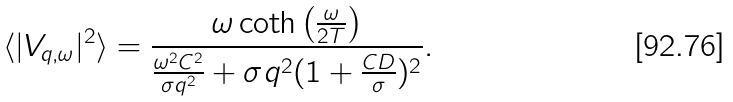Convert formula to latex. <formula><loc_0><loc_0><loc_500><loc_500>\langle | V _ { q , \omega } | ^ { 2 } \rangle = \frac { \omega \coth \left ( \frac { \omega } { 2 T } \right ) } { \frac { \omega ^ { 2 } C ^ { 2 } } { \sigma q ^ { 2 } } + \sigma q ^ { 2 } ( 1 + \frac { C D } { \sigma } ) ^ { 2 } } .</formula> 